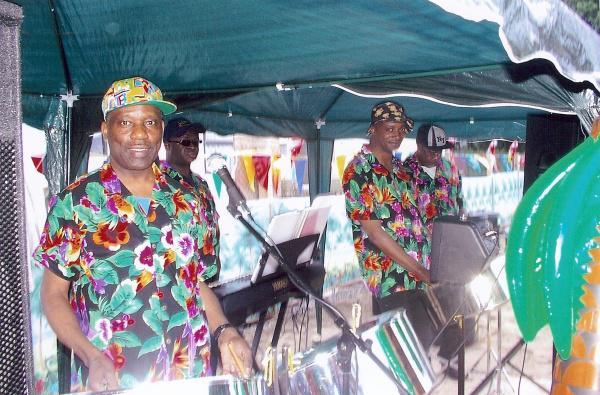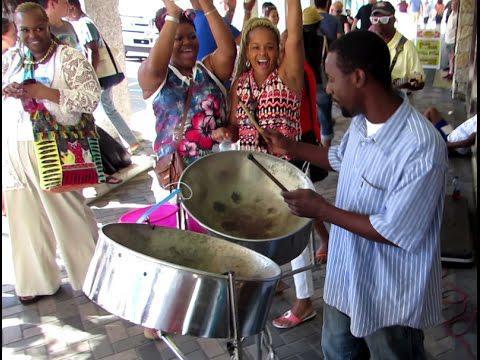The first image is the image on the left, the second image is the image on the right. Evaluate the accuracy of this statement regarding the images: "Each image includes at least three men standing behind drums, and at least one man in each image is wearing a hawaiian shirt.". Is it true? Answer yes or no. No. The first image is the image on the left, the second image is the image on the right. Given the left and right images, does the statement "Some musicians are wearing hats." hold true? Answer yes or no. Yes. 